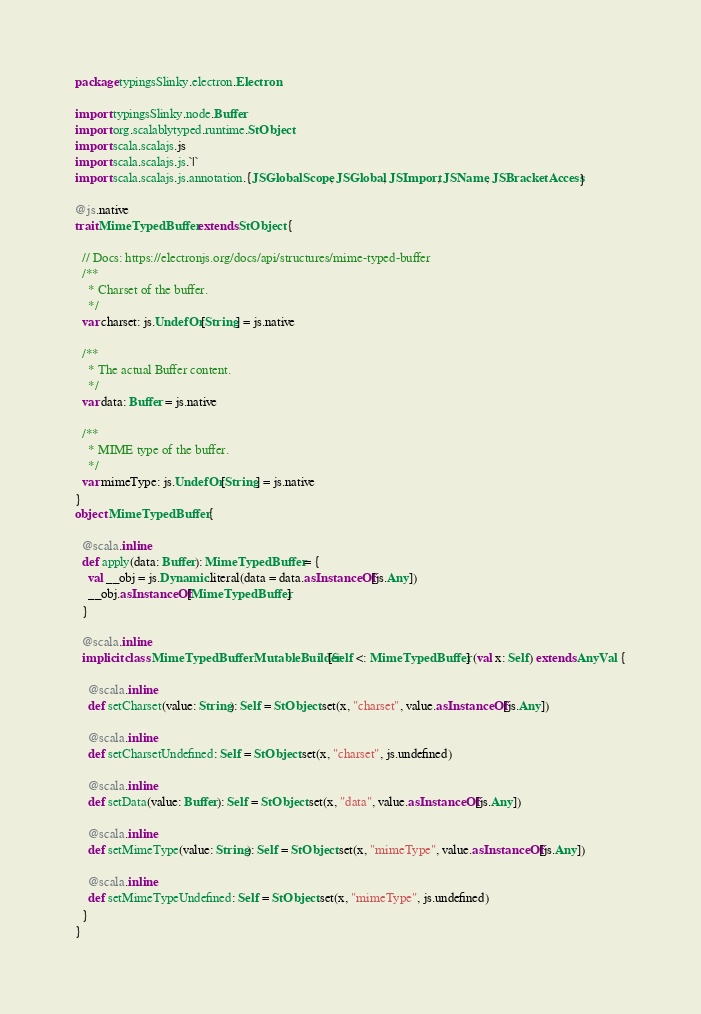Convert code to text. <code><loc_0><loc_0><loc_500><loc_500><_Scala_>package typingsSlinky.electron.Electron

import typingsSlinky.node.Buffer
import org.scalablytyped.runtime.StObject
import scala.scalajs.js
import scala.scalajs.js.`|`
import scala.scalajs.js.annotation.{JSGlobalScope, JSGlobal, JSImport, JSName, JSBracketAccess}

@js.native
trait MimeTypedBuffer extends StObject {
  
  // Docs: https://electronjs.org/docs/api/structures/mime-typed-buffer
  /**
    * Charset of the buffer.
    */
  var charset: js.UndefOr[String] = js.native
  
  /**
    * The actual Buffer content.
    */
  var data: Buffer = js.native
  
  /**
    * MIME type of the buffer.
    */
  var mimeType: js.UndefOr[String] = js.native
}
object MimeTypedBuffer {
  
  @scala.inline
  def apply(data: Buffer): MimeTypedBuffer = {
    val __obj = js.Dynamic.literal(data = data.asInstanceOf[js.Any])
    __obj.asInstanceOf[MimeTypedBuffer]
  }
  
  @scala.inline
  implicit class MimeTypedBufferMutableBuilder[Self <: MimeTypedBuffer] (val x: Self) extends AnyVal {
    
    @scala.inline
    def setCharset(value: String): Self = StObject.set(x, "charset", value.asInstanceOf[js.Any])
    
    @scala.inline
    def setCharsetUndefined: Self = StObject.set(x, "charset", js.undefined)
    
    @scala.inline
    def setData(value: Buffer): Self = StObject.set(x, "data", value.asInstanceOf[js.Any])
    
    @scala.inline
    def setMimeType(value: String): Self = StObject.set(x, "mimeType", value.asInstanceOf[js.Any])
    
    @scala.inline
    def setMimeTypeUndefined: Self = StObject.set(x, "mimeType", js.undefined)
  }
}
</code> 